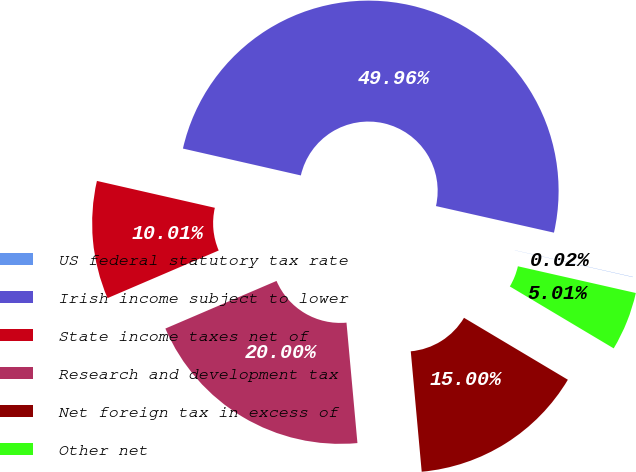Convert chart to OTSL. <chart><loc_0><loc_0><loc_500><loc_500><pie_chart><fcel>US federal statutory tax rate<fcel>Irish income subject to lower<fcel>State income taxes net of<fcel>Research and development tax<fcel>Net foreign tax in excess of<fcel>Other net<nl><fcel>0.02%<fcel>49.96%<fcel>10.01%<fcel>20.0%<fcel>15.0%<fcel>5.01%<nl></chart> 